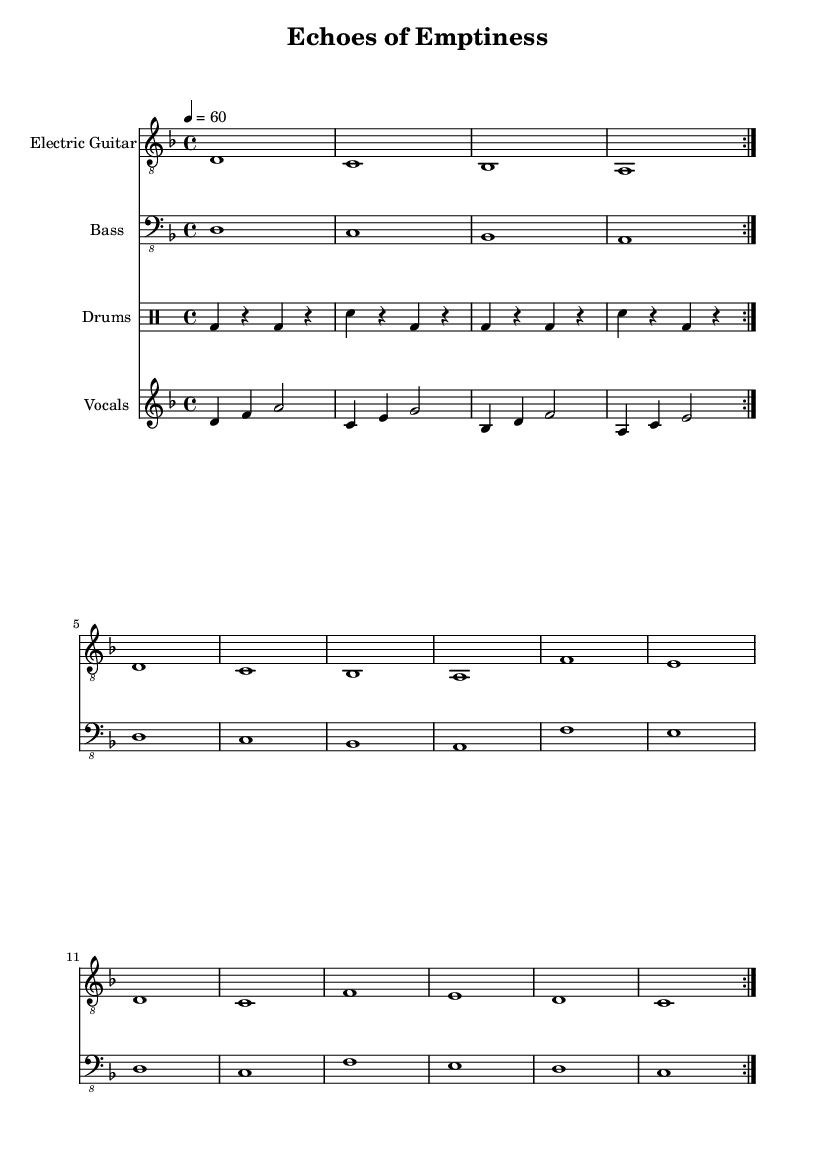What is the key signature of this music? The key signature shown in the music is D minor, which has one flat (B flat). This can be determined from the key signature at the beginning of the score, which indicates the tonal center of the piece.
Answer: D minor What is the time signature of this music? The time signature indicated in the music is 4/4, meaning there are four beats in each measure and the quarter note gets one beat. This can be seen at the beginning of the score just after the key signature.
Answer: 4/4 What is the tempo marking of this music? The tempo marking is 60 beats per minute, indicated in the score. This means that one quarter note will be played every second, giving a slow and deliberate feel appropriate for doom metal.
Answer: 60 How many times is the main riff repeated? The main riff is indicated to be repeated 2 times in the score, as denoted by the "volta" markings. These repeat signs show that the sections should be played through twice in succession.
Answer: 2 What is the vocal range indicated in this music? The vocal part is written in the treble clef in the fourth octave, starting from D and moving up to G, indicating a range generally suitable for many male or female vocalists. This can be inferred from the notation and the starting pitch.
Answer: D to G What type of drums are used in this piece? The drum section uses bass drum, snare drum, and rests appropriately as indicated in the drummode notation. This is typical in metal music to create a heavy rhythm.
Answer: Bass and snare What is the dominant theme expressed in the lyrics? The dominant theme expressed through the vocal lines in the music is about solitude and emptiness, as hinted by the title "Echoes of Emptiness." This theme resonates deeply in metal, especially in doom subgenres that focus on melancholy elements.
Answer: Solitude and emptiness 